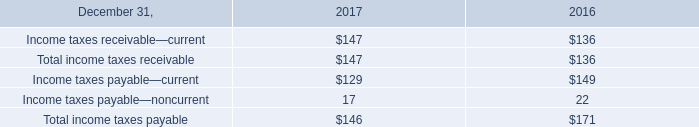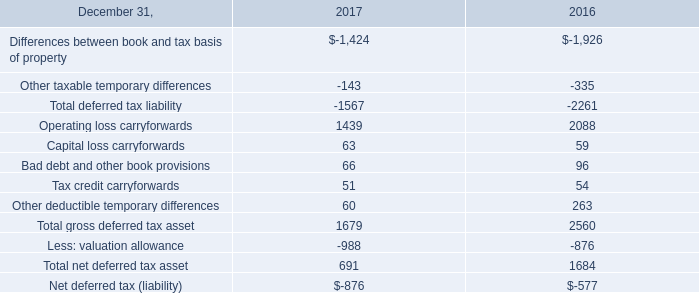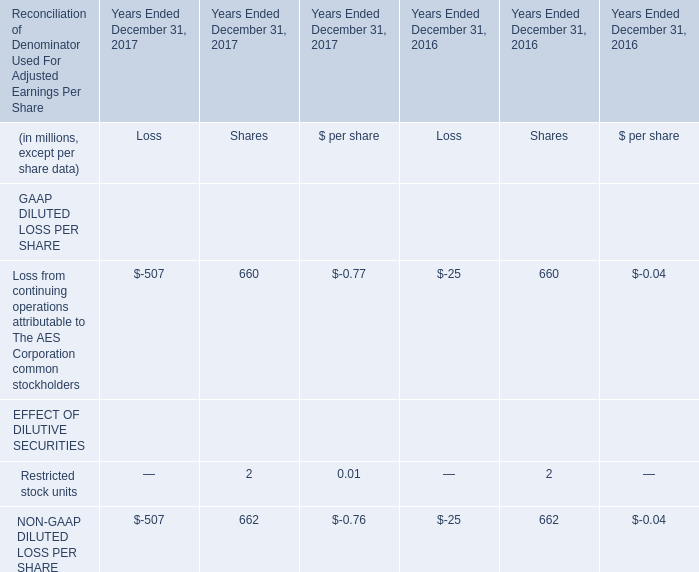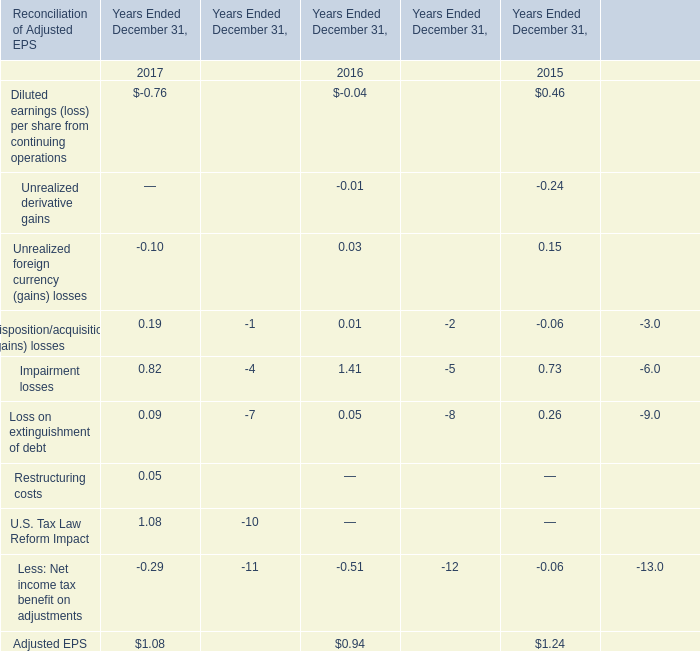What's the sum of Loss from continuing operations attributable to The AES Corporation common stockholders in 2017? (in million) 
Computations: (-507 + 660)
Answer: 153.0. 